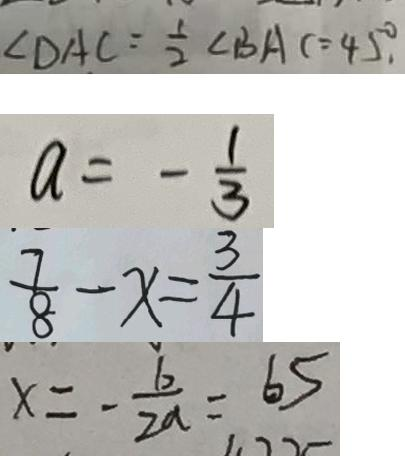Convert formula to latex. <formula><loc_0><loc_0><loc_500><loc_500>\angle D A C = \frac { 1 } { 2 } \angle B A C = 4 5 ^ { \circ } . 
 a = - \frac { 1 } { 3 } 
 \frac { 7 } { 8 } - x = \frac { 3 } { 4 } 
 x = - \frac { b } { 2 a } = 6 5</formula> 